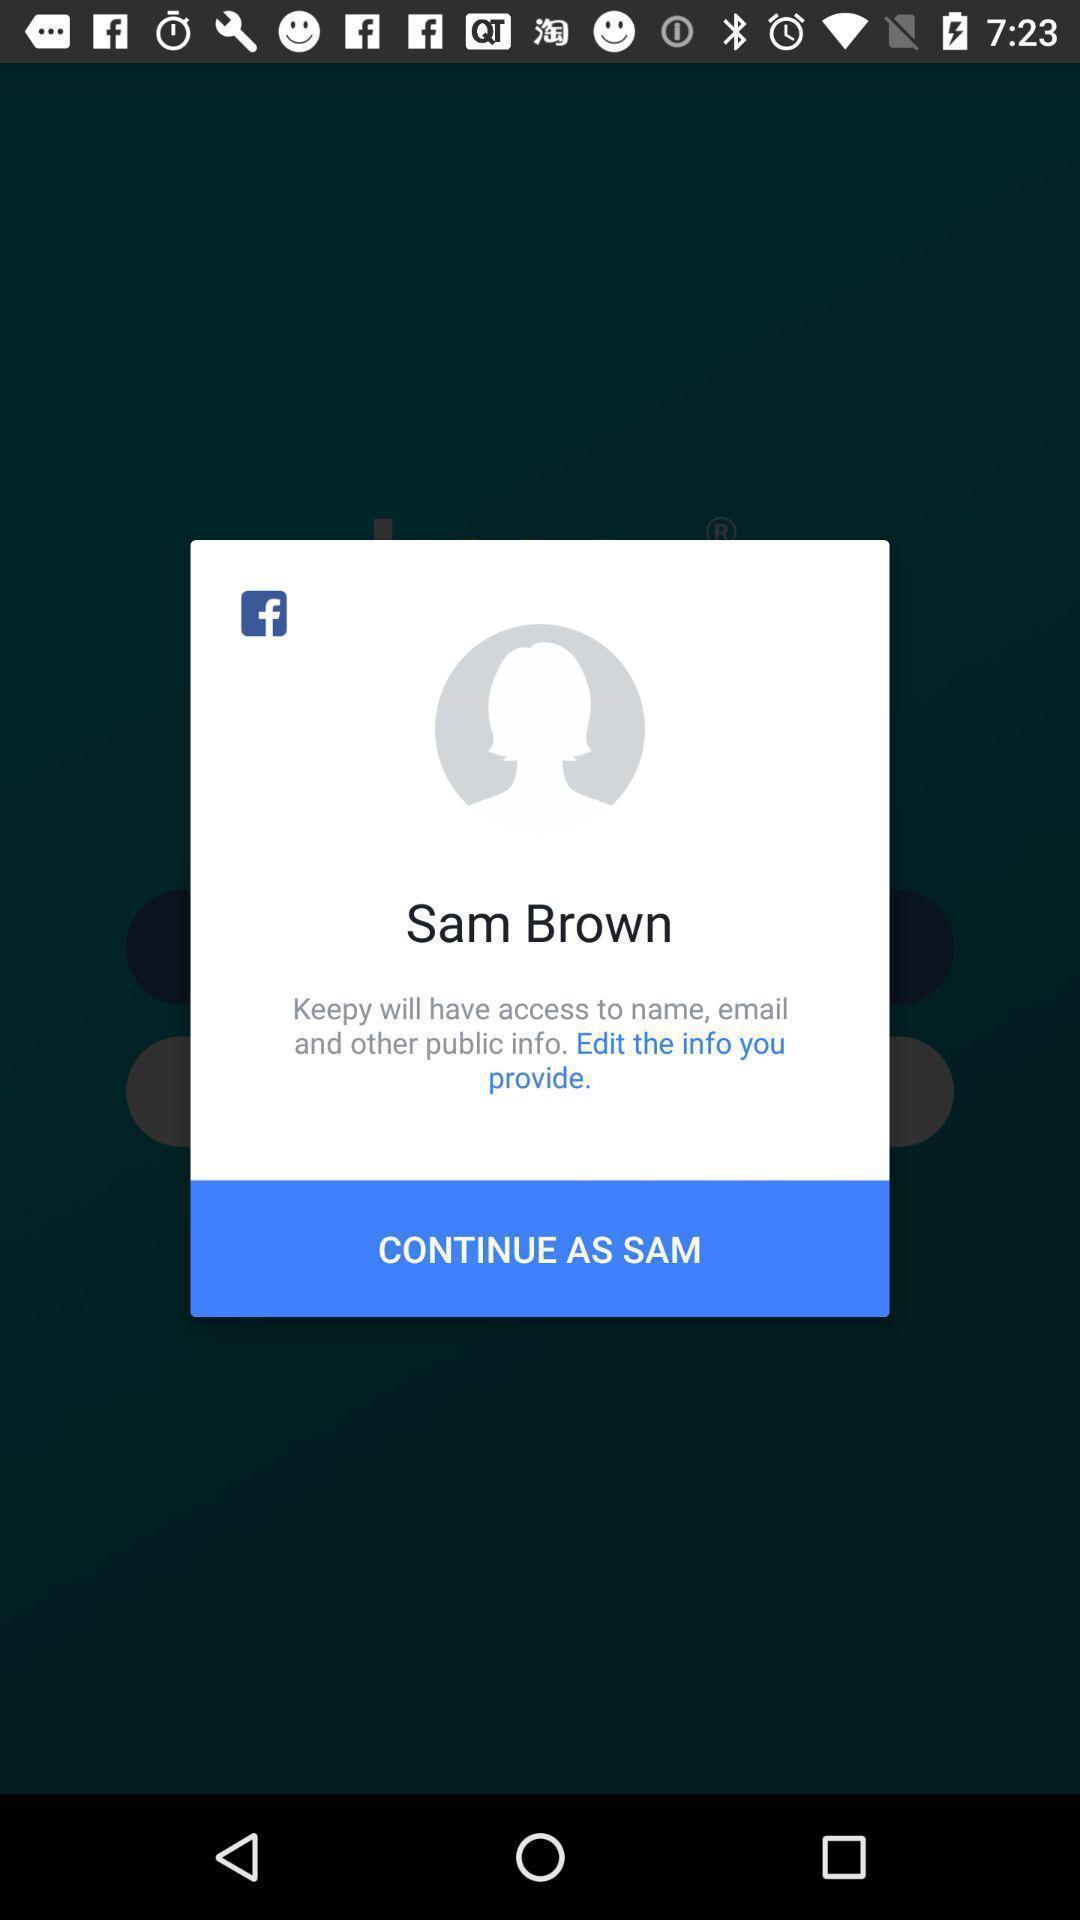Please provide a description for this image. Pop-up asking permission to allow for continuation. 